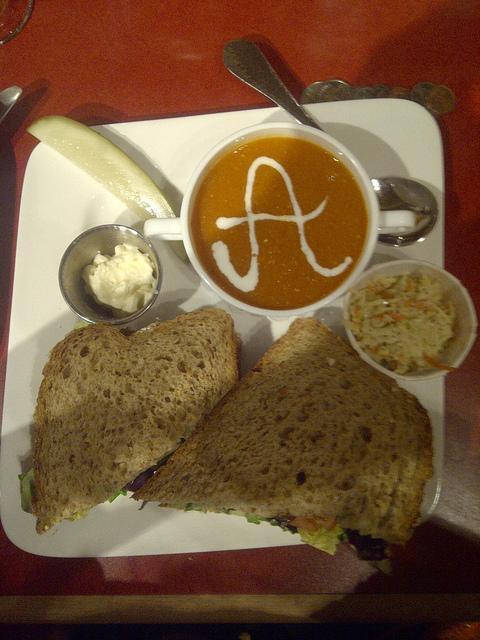How many bowls are there?
Give a very brief answer. 2. 